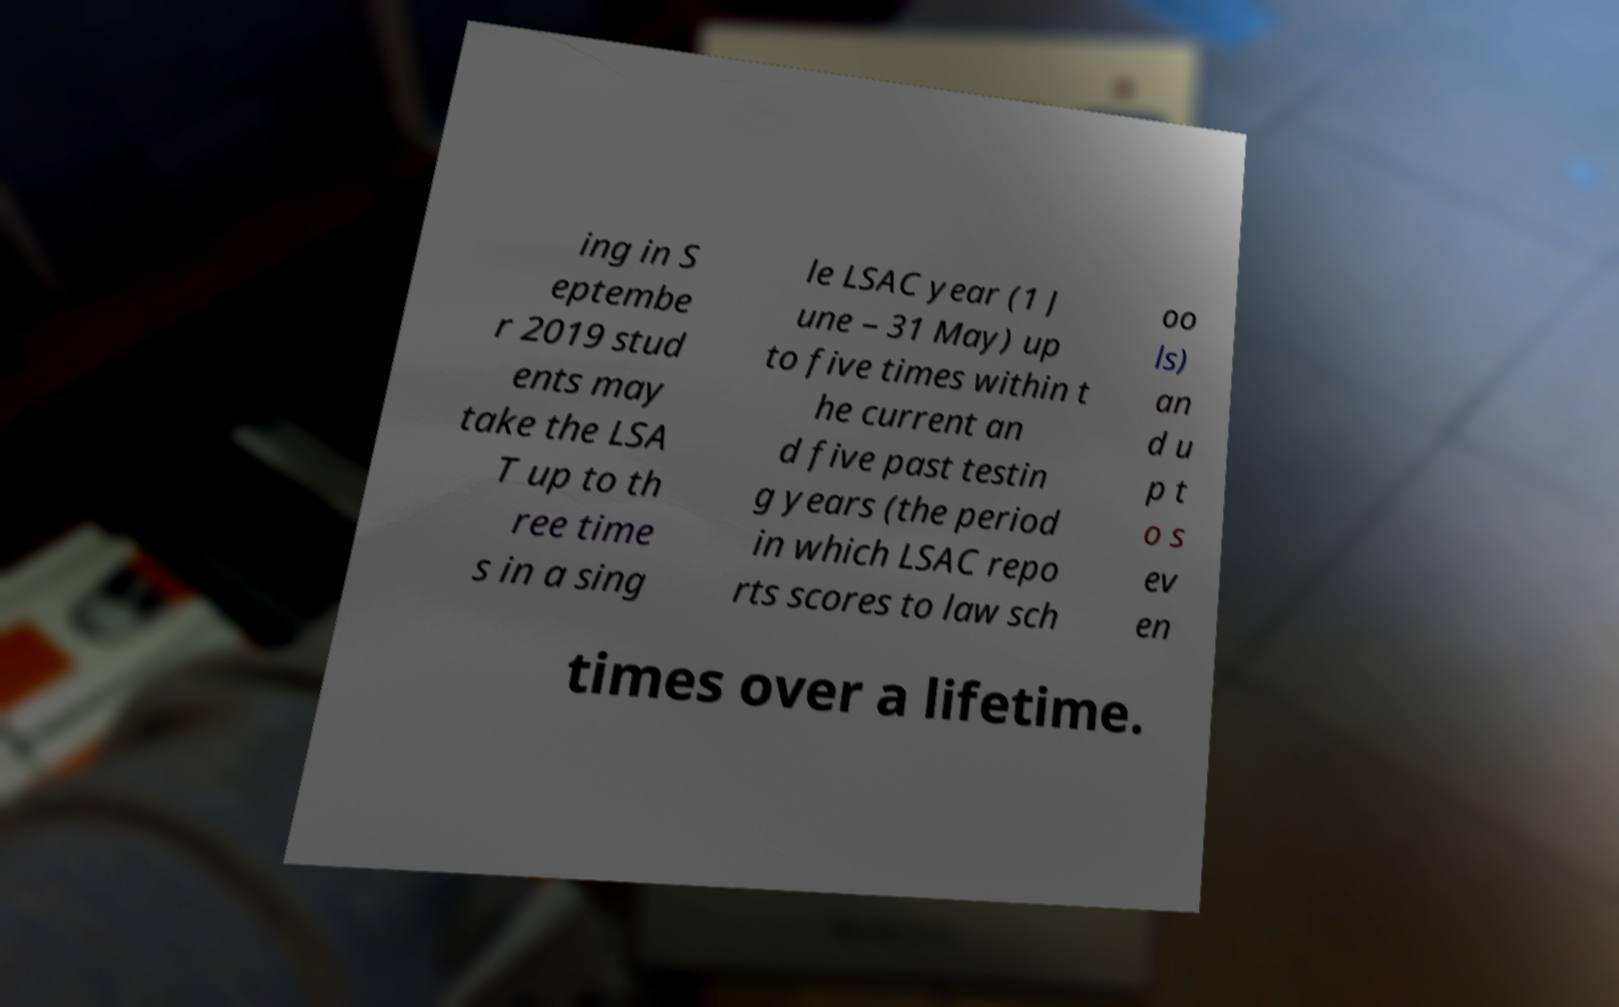Please read and relay the text visible in this image. What does it say? ing in S eptembe r 2019 stud ents may take the LSA T up to th ree time s in a sing le LSAC year (1 J une – 31 May) up to five times within t he current an d five past testin g years (the period in which LSAC repo rts scores to law sch oo ls) an d u p t o s ev en times over a lifetime. 